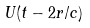<formula> <loc_0><loc_0><loc_500><loc_500>U ( t - 2 r / c )</formula> 